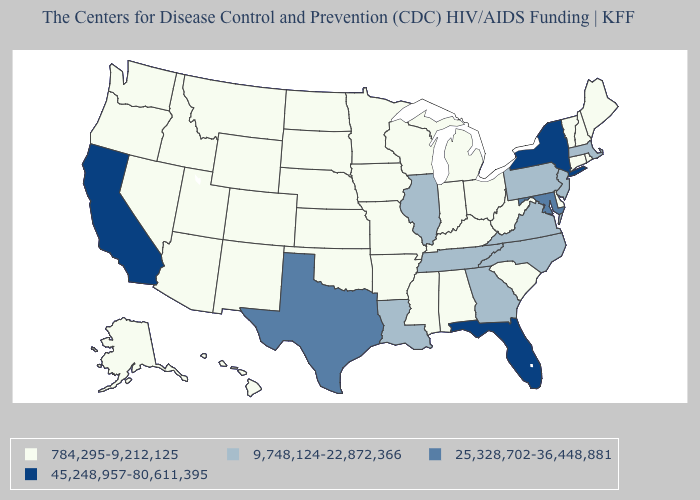Which states have the lowest value in the Northeast?
Give a very brief answer. Connecticut, Maine, New Hampshire, Rhode Island, Vermont. What is the lowest value in states that border Massachusetts?
Give a very brief answer. 784,295-9,212,125. What is the value of California?
Answer briefly. 45,248,957-80,611,395. Among the states that border North Dakota , which have the lowest value?
Be succinct. Minnesota, Montana, South Dakota. How many symbols are there in the legend?
Write a very short answer. 4. Does Washington have the same value as Florida?
Concise answer only. No. What is the value of Arkansas?
Be succinct. 784,295-9,212,125. What is the highest value in the MidWest ?
Answer briefly. 9,748,124-22,872,366. Among the states that border Wisconsin , does Michigan have the lowest value?
Write a very short answer. Yes. Is the legend a continuous bar?
Answer briefly. No. What is the value of Tennessee?
Answer briefly. 9,748,124-22,872,366. Name the states that have a value in the range 25,328,702-36,448,881?
Concise answer only. Maryland, Texas. Name the states that have a value in the range 784,295-9,212,125?
Give a very brief answer. Alabama, Alaska, Arizona, Arkansas, Colorado, Connecticut, Delaware, Hawaii, Idaho, Indiana, Iowa, Kansas, Kentucky, Maine, Michigan, Minnesota, Mississippi, Missouri, Montana, Nebraska, Nevada, New Hampshire, New Mexico, North Dakota, Ohio, Oklahoma, Oregon, Rhode Island, South Carolina, South Dakota, Utah, Vermont, Washington, West Virginia, Wisconsin, Wyoming. Is the legend a continuous bar?
Quick response, please. No. What is the value of South Dakota?
Keep it brief. 784,295-9,212,125. 